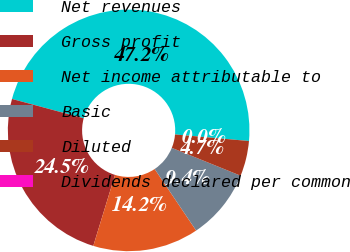<chart> <loc_0><loc_0><loc_500><loc_500><pie_chart><fcel>Net revenues<fcel>Gross profit<fcel>Net income attributable to<fcel>Basic<fcel>Diluted<fcel>Dividends declared per common<nl><fcel>47.21%<fcel>24.46%<fcel>14.16%<fcel>9.44%<fcel>4.72%<fcel>0.0%<nl></chart> 